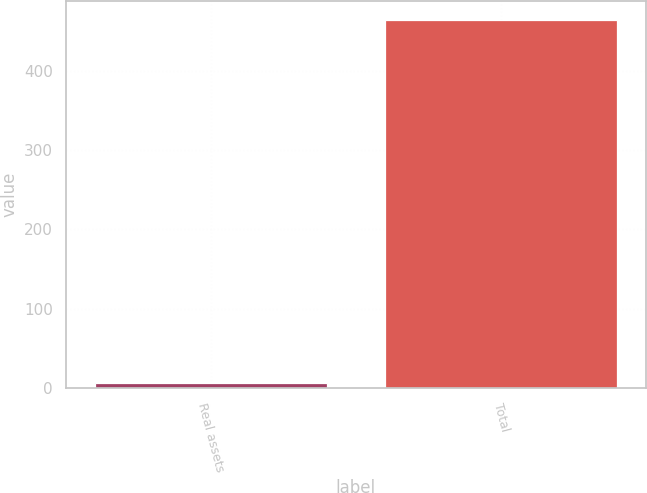Convert chart. <chart><loc_0><loc_0><loc_500><loc_500><bar_chart><fcel>Real assets<fcel>Total<nl><fcel>6<fcel>464<nl></chart> 